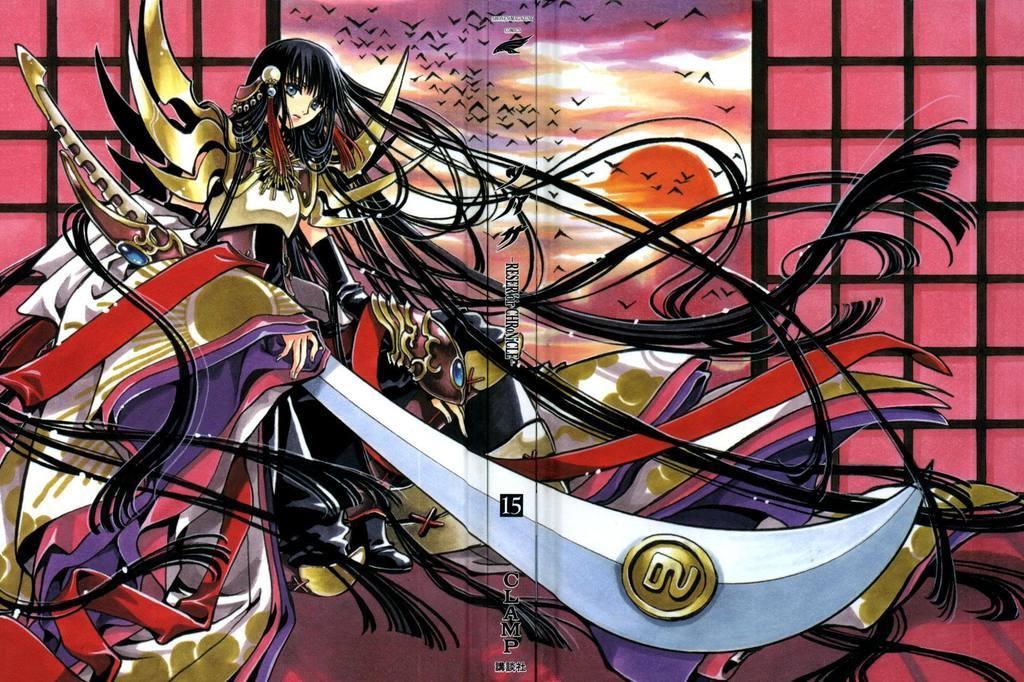What type of image is being described? The image is animated. What is the person in the image holding? The person is holding a knife in the image. What can be seen in the background of the image? There is a window and black birds visible in the background. How is the sun depicted in the image? The sun is depicted in an orange color. What type of bone can be seen in the image? There is no bone present in the image. What type of coach is visible in the image? There is no coach present in the image. 